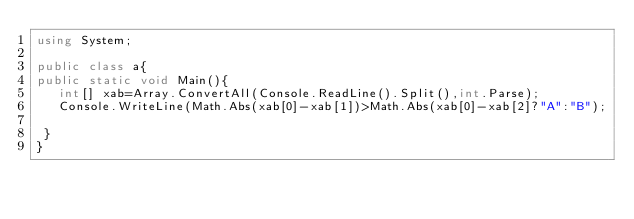<code> <loc_0><loc_0><loc_500><loc_500><_C#_>using System;

public class a{
public static void Main(){
   int[] xab=Array.ConvertAll(Console.ReadLine().Split(),int.Parse);
   Console.WriteLine(Math.Abs(xab[0]-xab[1])>Math.Abs(xab[0]-xab[2]?"A":"B");
                     
 }
}
</code> 